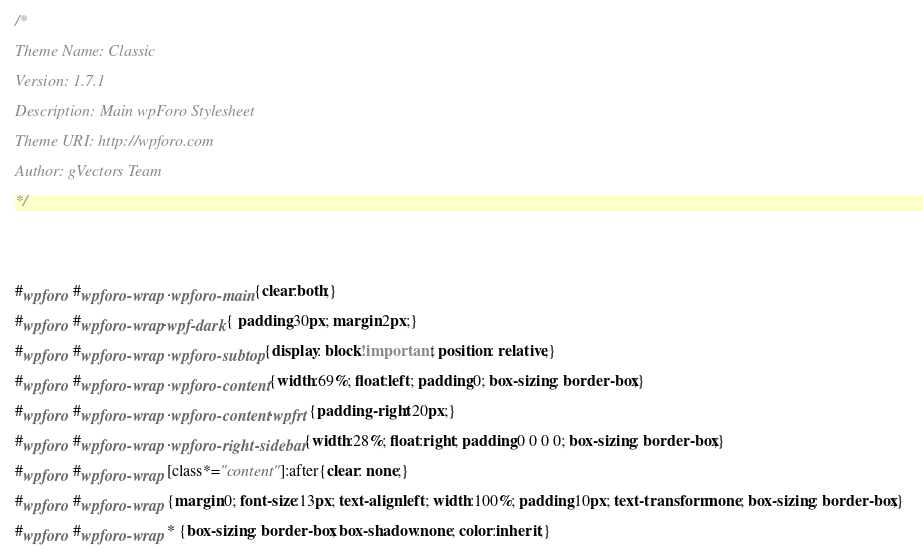<code> <loc_0><loc_0><loc_500><loc_500><_CSS_>/* 
Theme Name: Classic
Version: 1.7.1
Description: Main wpForo Stylesheet
Theme URI: http://wpforo.com
Author: gVectors Team
*/


#wpforo #wpforo-wrap .wpforo-main{clear:both;}
#wpforo #wpforo-wrap.wpf-dark{ padding:30px; margin:2px;}
#wpforo #wpforo-wrap .wpforo-subtop{display: block!important; position: relative;}
#wpforo #wpforo-wrap .wpforo-content{width:69%; float:left; padding:0; box-sizing: border-box;}
#wpforo #wpforo-wrap .wpforo-content.wpfrt{padding-right: 20px;}
#wpforo #wpforo-wrap .wpforo-right-sidebar{width:28%; float:right; padding:0 0 0 0; box-sizing: border-box;}
#wpforo #wpforo-wrap [class*="content"]:after{clear: none;}
#wpforo #wpforo-wrap {margin:0; font-size:13px; text-align:left; width:100%; padding:10px; text-transform:none; box-sizing: border-box;} 
#wpforo #wpforo-wrap * {box-sizing: border-box; box-shadow:none; color:inherit;}</code> 